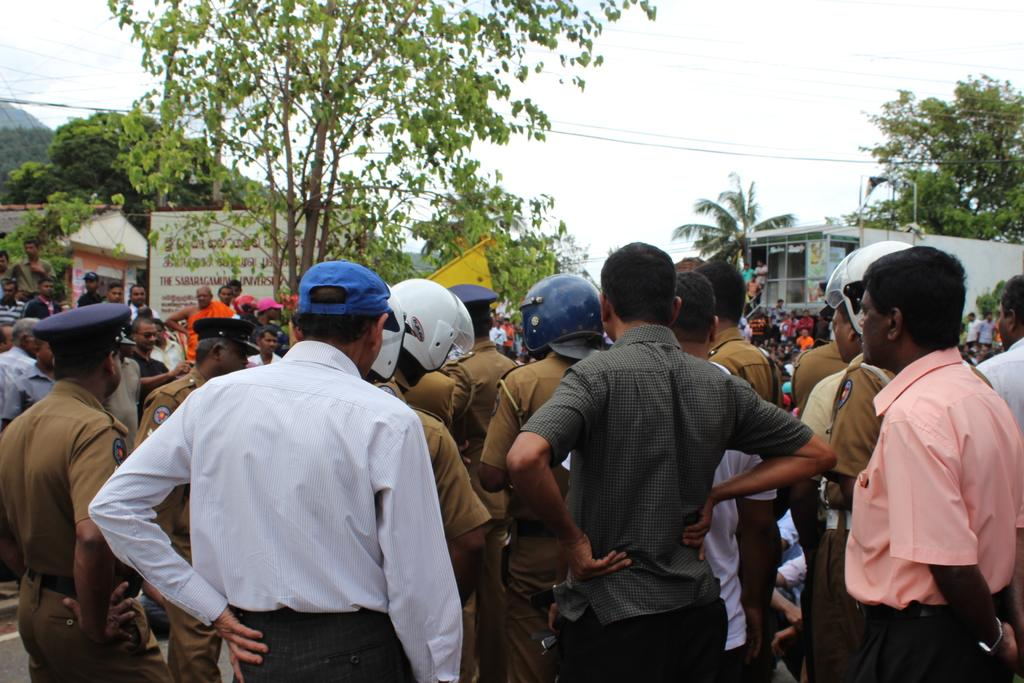What is the main subject of the image? The main subject of the image is a group of people standing. Can you identify the occupation of some of the people in the image? Yes, some of the people in the image are policemen. What type of headgear are the policemen wearing? Some of the policemen are wearing helmets, while others are wearing caps. What can be seen in the background of the image? There are trees and a building visible in the image. What object is present in the image that might be used for displaying information? There is a board present in the image. Can you tell me how many oceans are visible in the image? There are no oceans visible in the image; it features a group of people, including policemen, standing in front of trees and a building. 